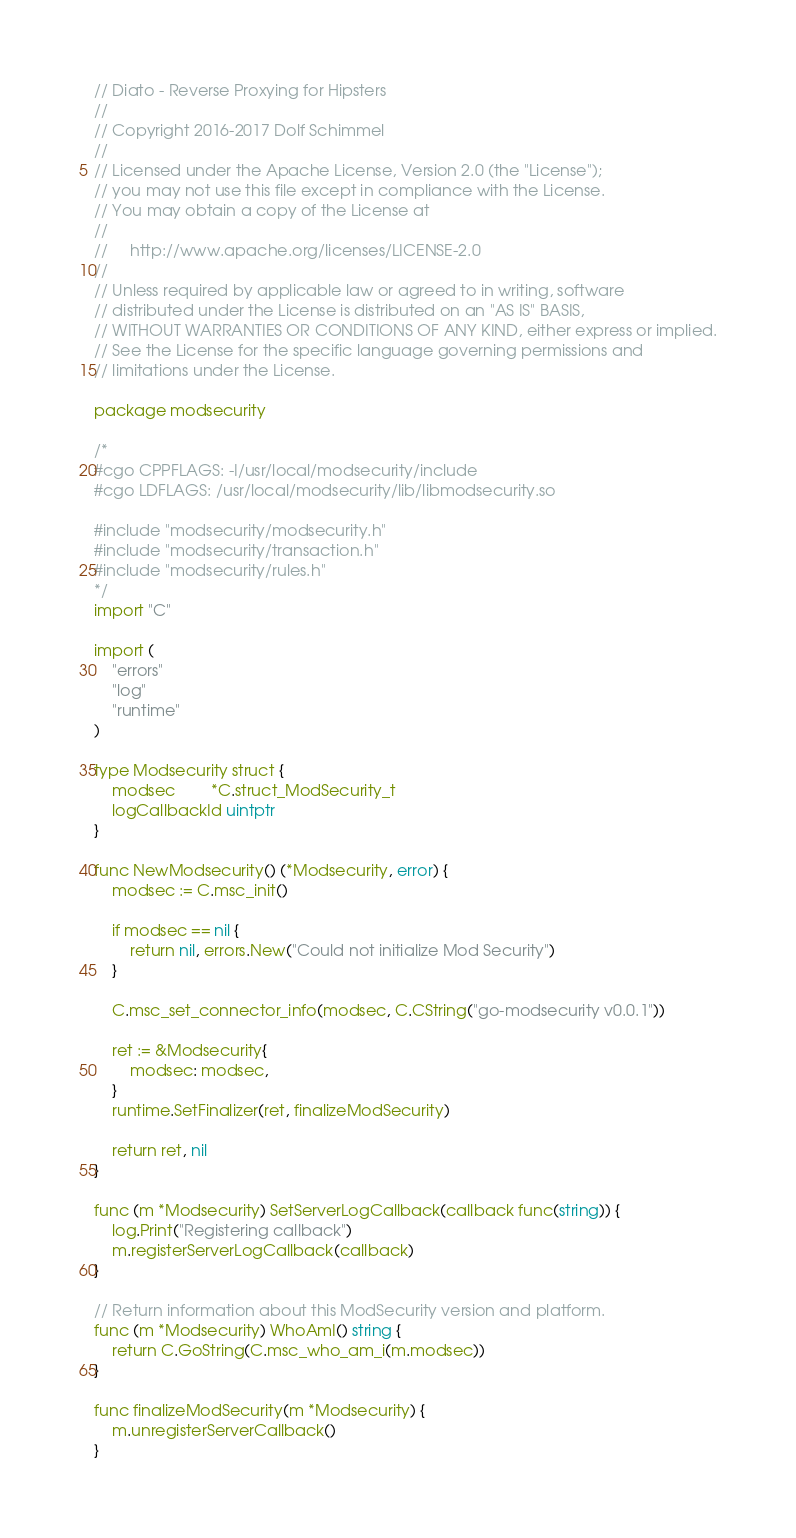<code> <loc_0><loc_0><loc_500><loc_500><_Go_>// Diato - Reverse Proxying for Hipsters
//
// Copyright 2016-2017 Dolf Schimmel
//
// Licensed under the Apache License, Version 2.0 (the "License");
// you may not use this file except in compliance with the License.
// You may obtain a copy of the License at
//
//     http://www.apache.org/licenses/LICENSE-2.0
//
// Unless required by applicable law or agreed to in writing, software
// distributed under the License is distributed on an "AS IS" BASIS,
// WITHOUT WARRANTIES OR CONDITIONS OF ANY KIND, either express or implied.
// See the License for the specific language governing permissions and
// limitations under the License.

package modsecurity

/*
#cgo CPPFLAGS: -I/usr/local/modsecurity/include
#cgo LDFLAGS: /usr/local/modsecurity/lib/libmodsecurity.so

#include "modsecurity/modsecurity.h"
#include "modsecurity/transaction.h"
#include "modsecurity/rules.h"
*/
import "C"

import (
	"errors"
	"log"
	"runtime"
)

type Modsecurity struct {
	modsec        *C.struct_ModSecurity_t
	logCallbackId uintptr
}

func NewModsecurity() (*Modsecurity, error) {
	modsec := C.msc_init()

	if modsec == nil {
		return nil, errors.New("Could not initialize Mod Security")
	}

	C.msc_set_connector_info(modsec, C.CString("go-modsecurity v0.0.1"))

	ret := &Modsecurity{
		modsec: modsec,
	}
	runtime.SetFinalizer(ret, finalizeModSecurity)

	return ret, nil
}

func (m *Modsecurity) SetServerLogCallback(callback func(string)) {
	log.Print("Registering callback")
	m.registerServerLogCallback(callback)
}

// Return information about this ModSecurity version and platform.
func (m *Modsecurity) WhoAmI() string {
	return C.GoString(C.msc_who_am_i(m.modsec))
}

func finalizeModSecurity(m *Modsecurity) {
	m.unregisterServerCallback()
}
</code> 